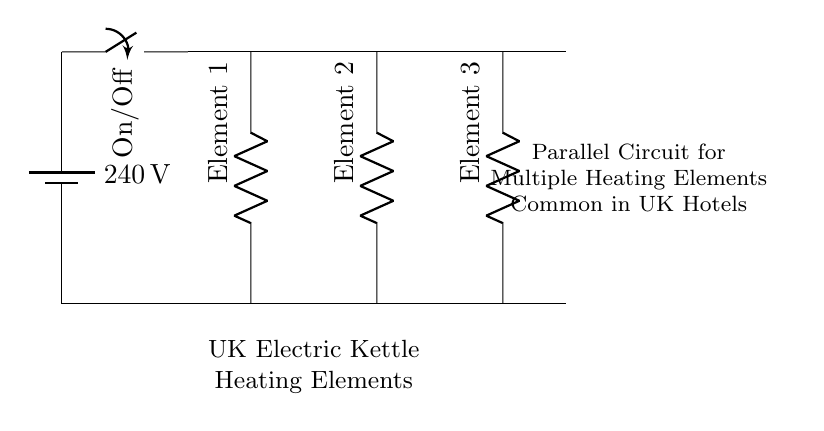What is the voltage of this circuit? The voltage is 240 volts, which is indicated by the battery symbol in the diagram.
Answer: 240 volts How many heating elements are there in the circuit? There are three heating elements, as represented by three resistor symbols in parallel.
Answer: Three What type of circuit is shown? The circuit is a parallel circuit, characterized by multiple components connected across the same two points allowing independent current flow through each element.
Answer: Parallel What is the purpose of the switch in this circuit? The switch controls the flow of current to the entire circuit, enabling or disabling the heating elements when it is turned on or off.
Answer: Control current flow What happens to the total resistance when more heating elements are added in parallel? The total resistance decreases as more parallel components are added because the overall current is distributed among more paths.
Answer: Decreases What is the total current flowing through the circuit when the switch is on? The total current can be calculated using the formula I = V/R, but specific values for resistance of each heating element are not given in the diagram, so a numerical answer isn’t available from the circuit itself.
Answer: Not determinable 